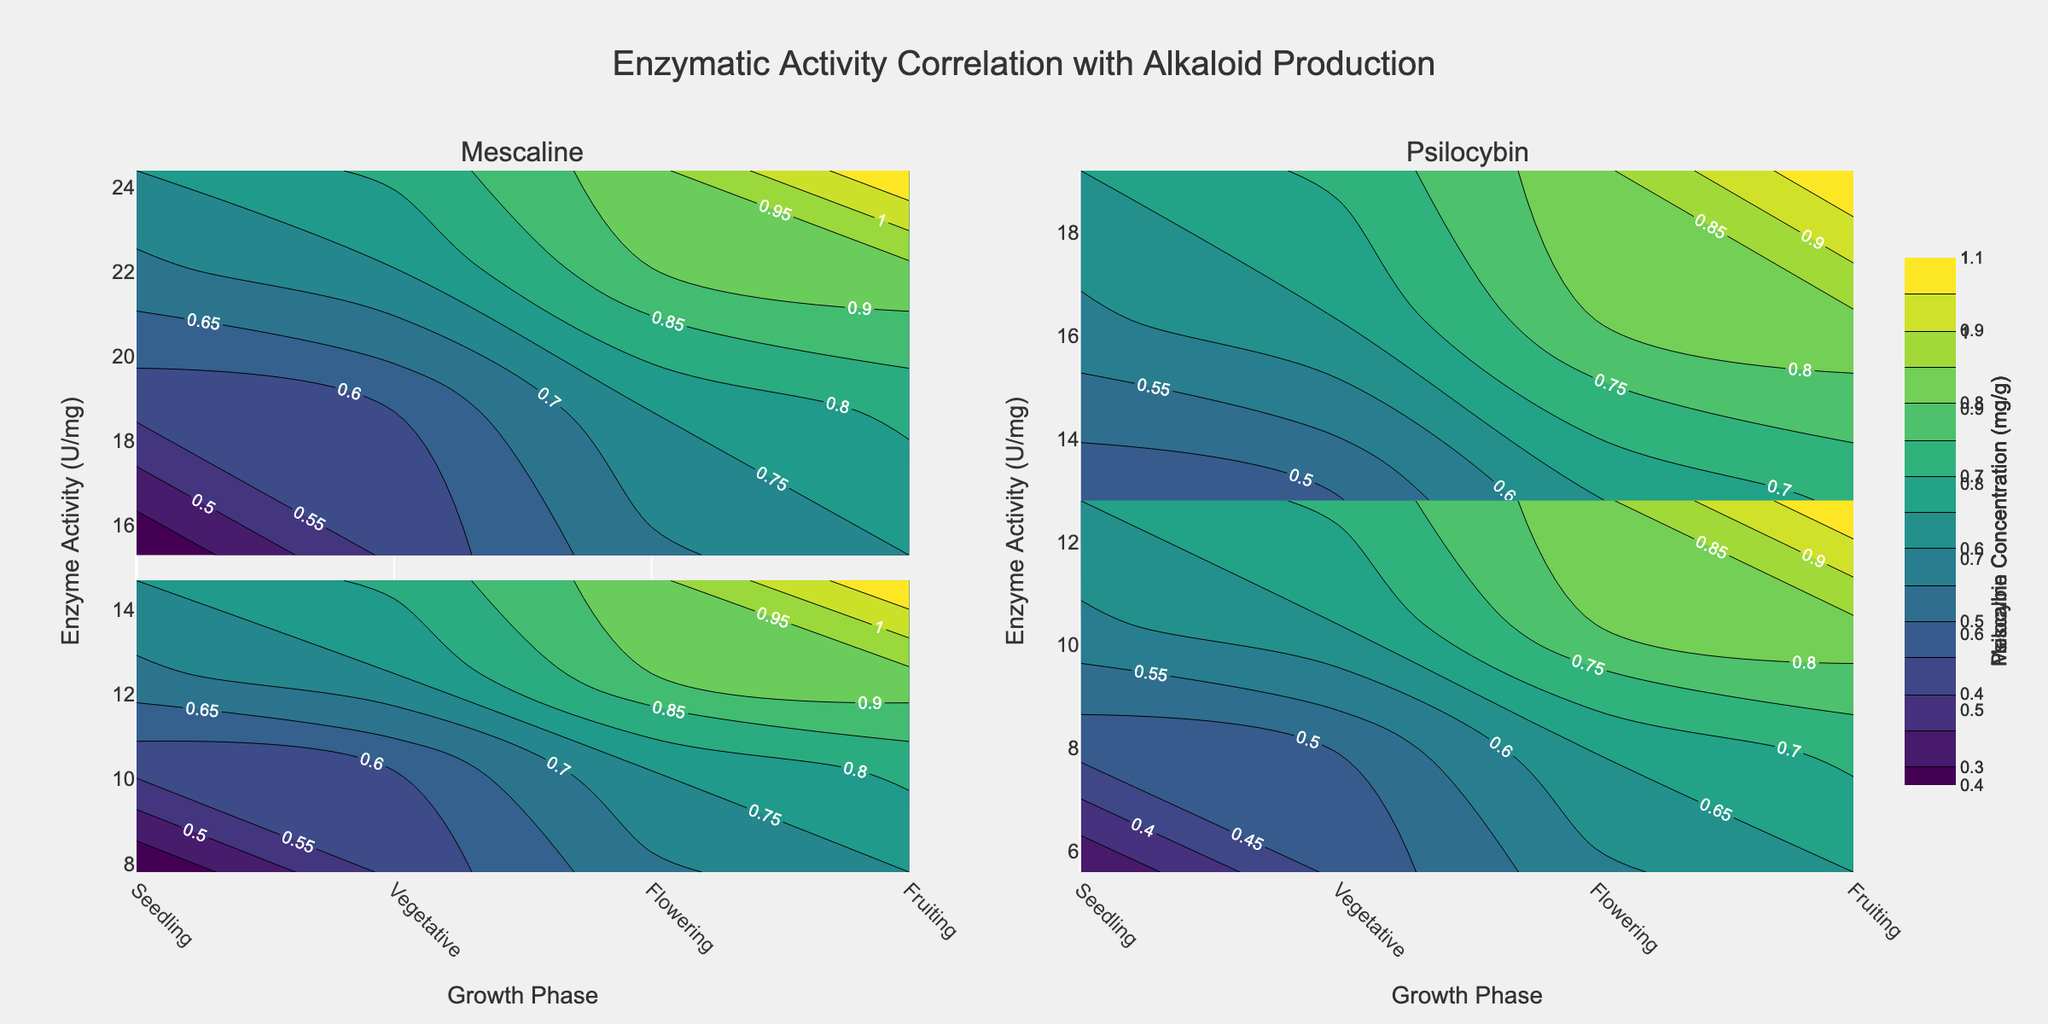what is shown in the first subplot title? The first subplot title shows the type of alkaloid being analyzed, which is one of the subjects of study in the plot. The specific alkaloid name is displayed at the top of the subplot.
Answer: Mescaline what is the color scale used in the contour plots? The color scale used in the contour plots helps to indicate the concentration levels of the alkaloids. By referring to the legend, we can see it is labeled with the concentration of the alkaloids in mg/g.
Answer: Viridis What are the variables represented on the x-axis and y-axis? The x-axis represents the growth phases (Seedling, Vegetative, Flowering, Fruiting), whereas the y-axis represents the enzyme activity measured in U/mg.
Answer: Growth Phases, Enzyme Activity (U/mg) In which growth phase does 'Tyrosine Decarboxylase' have the highest enzyme activity in relation to Mescaline production? By examining the contours, locate where the Tyrosine Decarboxylase enzyme has the highest activity level that correlates with Mescaline production. This is in the Fruiting phase.
Answer: Fruiting Compare the enzyme activity of 'L-Tryptophan Decarboxylase' and 'O-Methyltransferase' in the Flowering phase for Psilocybin production. Which enzyme has higher activity? Find the contours corresponding to the Flowering phase in the subplot for Psilocybin. Compare the enzyme activity levels of 'L-Tryptophan Decarboxylase' and 'O-Methyltransferase'. 'L-Tryptophan Decarboxylase' shows higher enzyme activity.
Answer: L-Tryptophan Decarboxylase What is the relationship between enzyme activity and alkaloid concentration for 'N-Methyltransferase' in the Vegetative phase for Mescaline production? By focusing on the Vegetative phase contours for 'N-Methyltransferase' and observing the z-values on the contour lines, there is an increase in alkaloid concentration as enzyme activity increases.
Answer: As enzyme activity increases, alkaloid concentration increases In which subplot and growth phase does 'L-Tryptophan Decarboxylase' show an enzyme activity level around 19.2 U/mg? Locate the subplot for Psilocybin. Identify the Fruiting phase where the enzyme 'L-Tryptophan Decarboxylase' shows the highest enzyme activity at approximately 19.2 U/mg.
Answer: Psilocybin, Fruiting What's the primary observational trend shown in the contours across different growth phases for both alkaloids? Overall, the trend indicates that enzyme activity increases, leading to higher concentrations of alkaloids in later growth phases such as Flowering and Fruiting.
Answer: Higher enzyme activity corresponds to higher alkaloid concentrations in later growth phases 